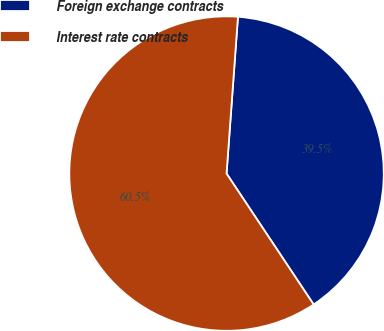Convert chart to OTSL. <chart><loc_0><loc_0><loc_500><loc_500><pie_chart><fcel>Foreign exchange contracts<fcel>Interest rate contracts<nl><fcel>39.5%<fcel>60.5%<nl></chart> 